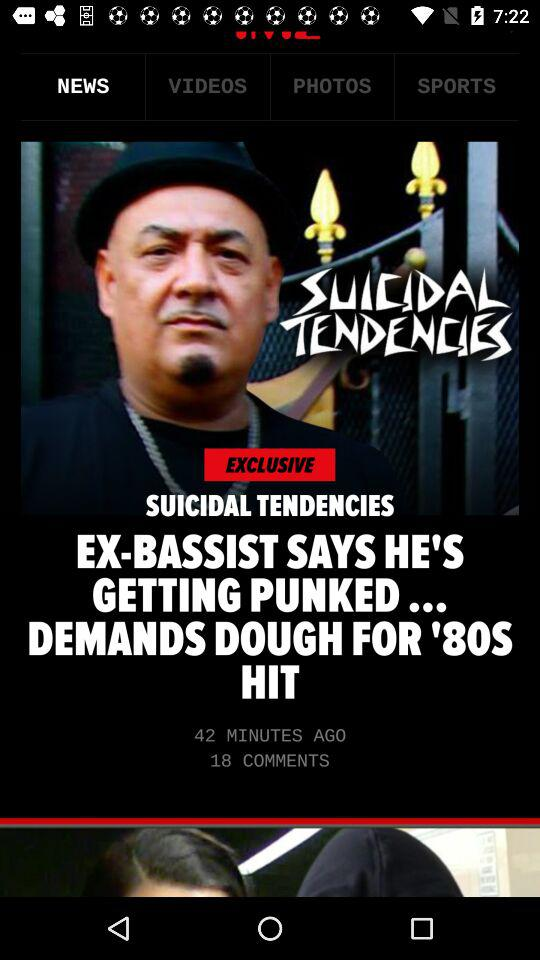Which tab is selected? The selected tab is "NEWS". 